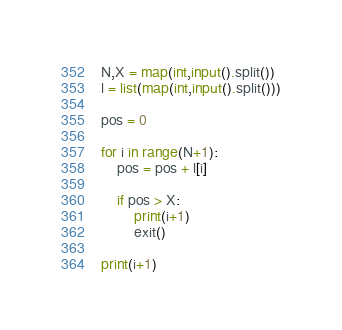Convert code to text. <code><loc_0><loc_0><loc_500><loc_500><_Python_>N,X = map(int,input().split())
l = list(map(int,input().split()))

pos = 0

for i in range(N+1):
    pos = pos + l[i]

    if pos > X:
        print(i+1)
        exit()

print(i+1)

</code> 